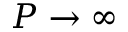<formula> <loc_0><loc_0><loc_500><loc_500>P \to \infty</formula> 